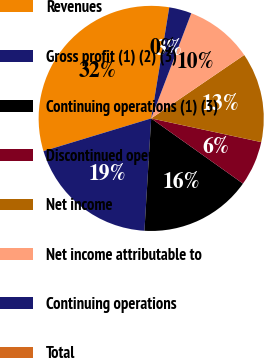<chart> <loc_0><loc_0><loc_500><loc_500><pie_chart><fcel>Revenues<fcel>Gross profit (1) (2) (3)<fcel>Continuing operations (1) (3)<fcel>Discontinued operations<fcel>Net income<fcel>Net income attributable to<fcel>Continuing operations<fcel>Total<nl><fcel>32.26%<fcel>19.35%<fcel>16.13%<fcel>6.45%<fcel>12.9%<fcel>9.68%<fcel>3.23%<fcel>0.0%<nl></chart> 